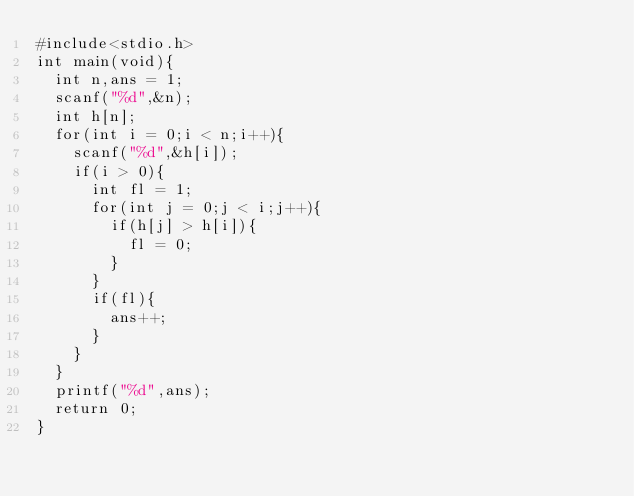Convert code to text. <code><loc_0><loc_0><loc_500><loc_500><_C_>#include<stdio.h>
int main(void){
  int n,ans = 1;
  scanf("%d",&n);
  int h[n];
  for(int i = 0;i < n;i++){
    scanf("%d",&h[i]);
    if(i > 0){
      int fl = 1;
      for(int j = 0;j < i;j++){
        if(h[j] > h[i]){
          fl = 0;
        }
      }
      if(fl){
        ans++;
      }
    }
  }
  printf("%d",ans);
  return 0;
}</code> 